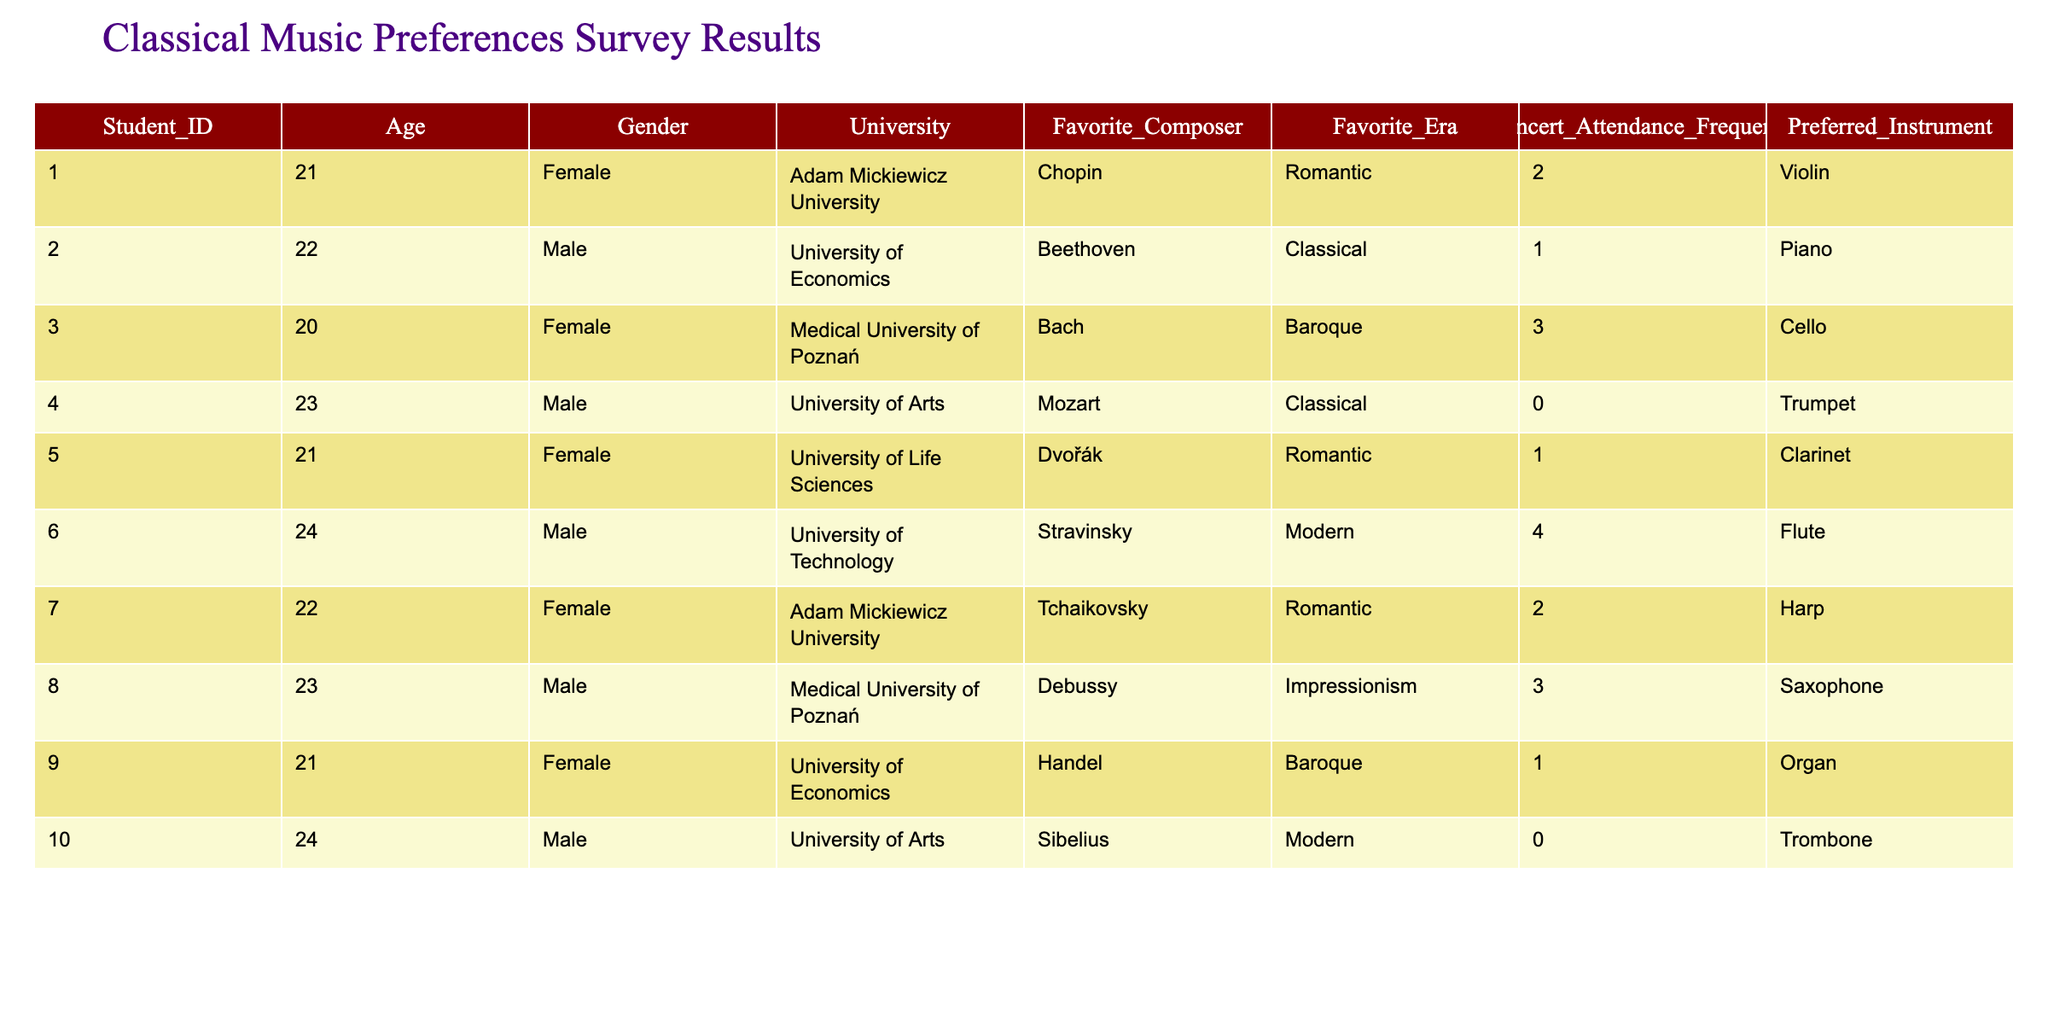What is the most preferred era among the surveyed students? By examining the "Favorite_Era" column, we see that the most frequently occurring entries are Romantic (with 4 students) and Classical (with 3 students). Thus, Romantic is the most preferred era.
Answer: Romantic How many students frequently attend concerts at least once a month? Looking at the "Concert_Attendance_Frequency" column, students who attend concerts 1, 2, 3, or more times monthly are counted. There are 6 students who attend at least once a month (1, 2, or 3 times).
Answer: 6 Which university has a student that prefers the flute? Examining the "Preferred_Instrument" column paired with "University," we find that the University of Technology has one student who prefers the flute.
Answer: University of Technology Is there a student who prefers a modern composer and attends concerts regularly? Checking the "Favorite_Composer" and "Concert_Attendance_Frequency," there is a student from the University of Technology who prefers Stravinsky (a modern composer) and attends concerts 4 times, indicating regular attendance.
Answer: Yes What is the average age of students who prefer Baroque music? Focusing on students with "Favorite_Era" equal to Baroque, we note their ages: 20 (Bach) and 21 (Handel), summing these gives 41. Dividing by the number of students (2) results in an average of 20.5.
Answer: 20.5 